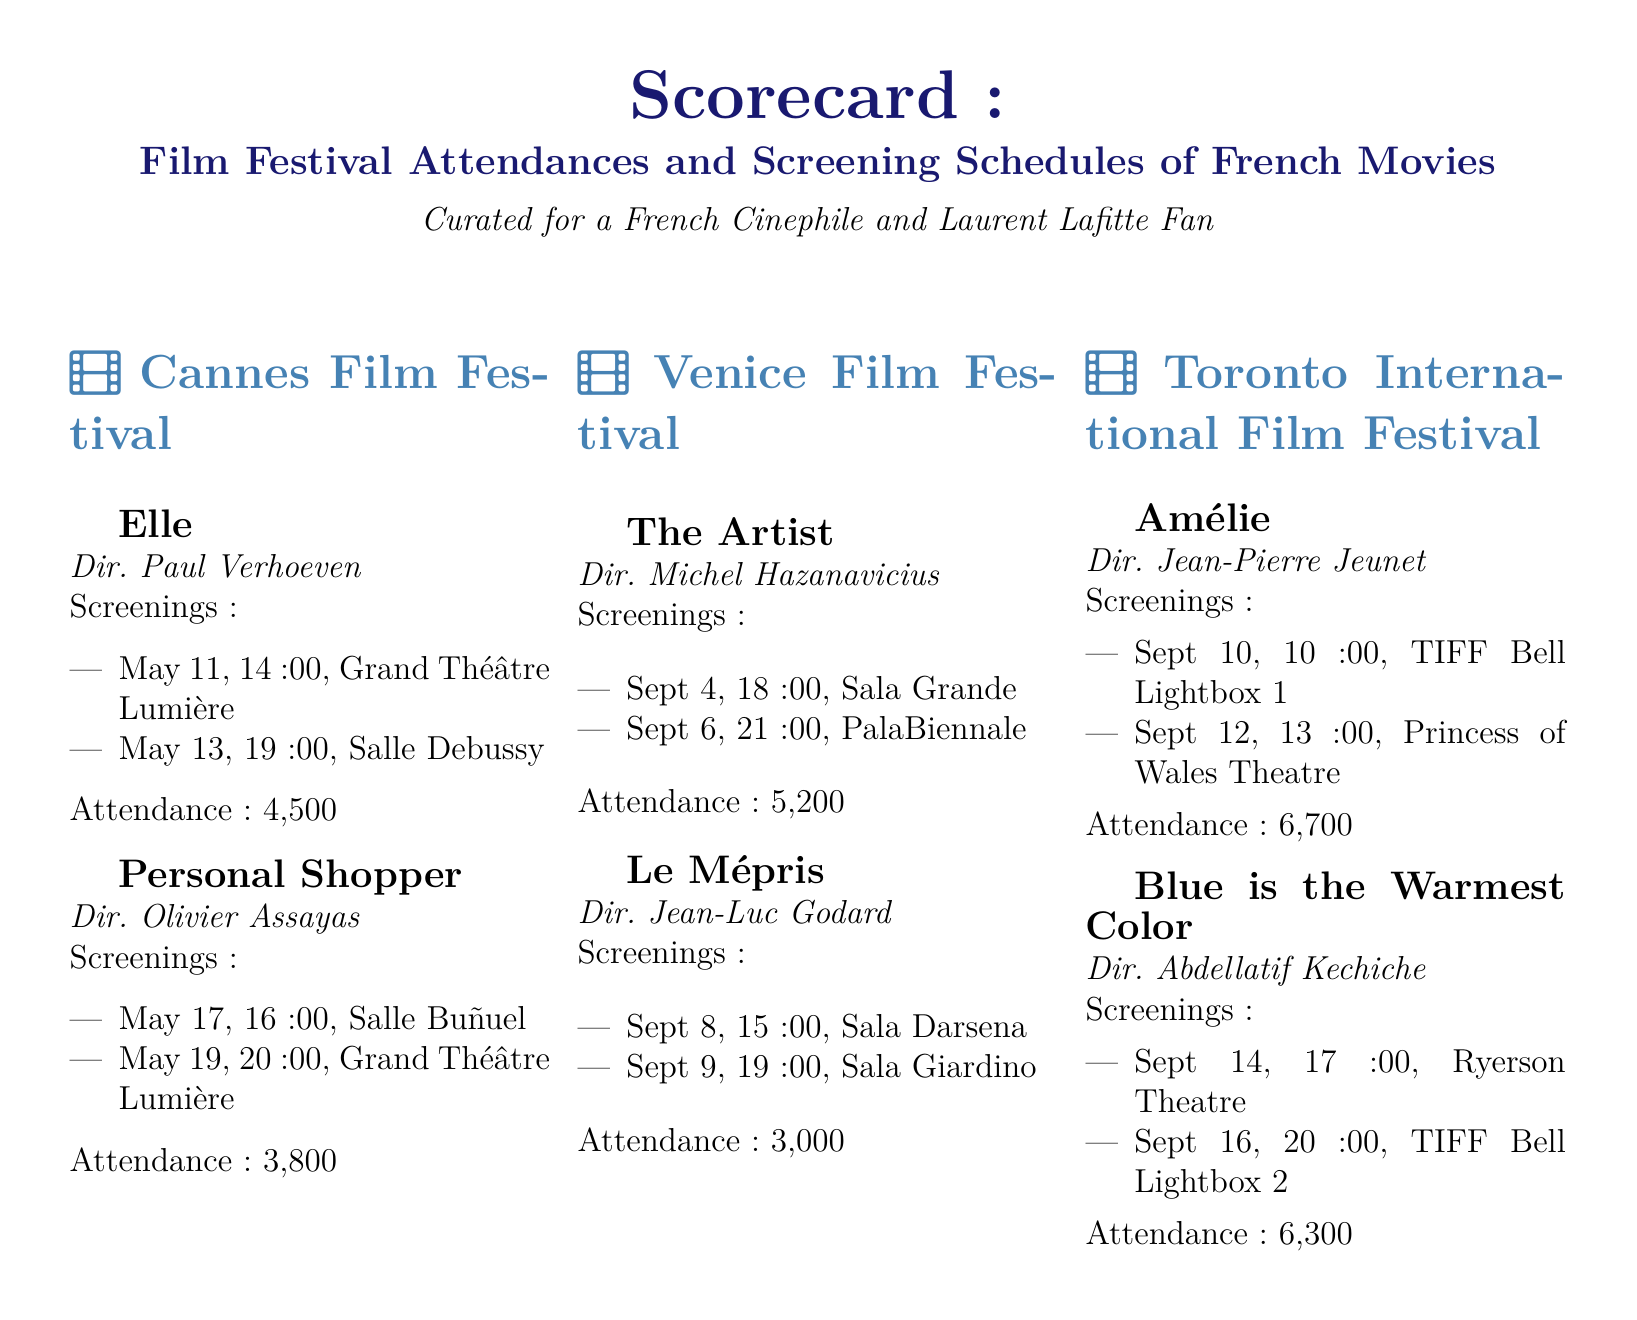What is the title of the film directed by Paul Verhoeven? The document lists "Elle" as the film directed by Paul Verhoeven.
Answer: Elle What is the attendance for "Amélie"? The attendance for "Amélie" is provided in the document as 6,700.
Answer: 6,700 On which date is "Le Mépris" screened at Sala Darsena? The document specifies that "Le Mépris" is screened at Sala Darsena on September 8.
Answer: Sept 8 How many screenings does "Blue is the Warmest Color" have? The total number of screenings for "Blue is the Warmest Color," as stated in the document, is two.
Answer: two Which film has the highest attendance at the Toronto International Film Festival? The document indicates that "Amélie" has the highest attendance among the films listed at the Toronto International Film Festival.
Answer: Amélie What is the screening time for "Personal Shopper" on May 19? "Personal Shopper" is scheduled to screen at 20:00 on May 19, according to the document.
Answer: 20:00 Which director appears most frequently in the document? The document lists Paul Verhoeven, Olivier Assayas, Michel Hazanavicius, Jean-Luc Godard, Jean-Pierre Jeunet, and Abdellatif Kechiche; however, none are repeated.
Answer: none What type of event does this scorecard pertain to? The scorecard is curated for film festivals, which is specified in the title.
Answer: film festivals Which festival features "Elle"? The document states that "Elle" is featured at the Cannes Film Festival.
Answer: Cannes Film Festival 